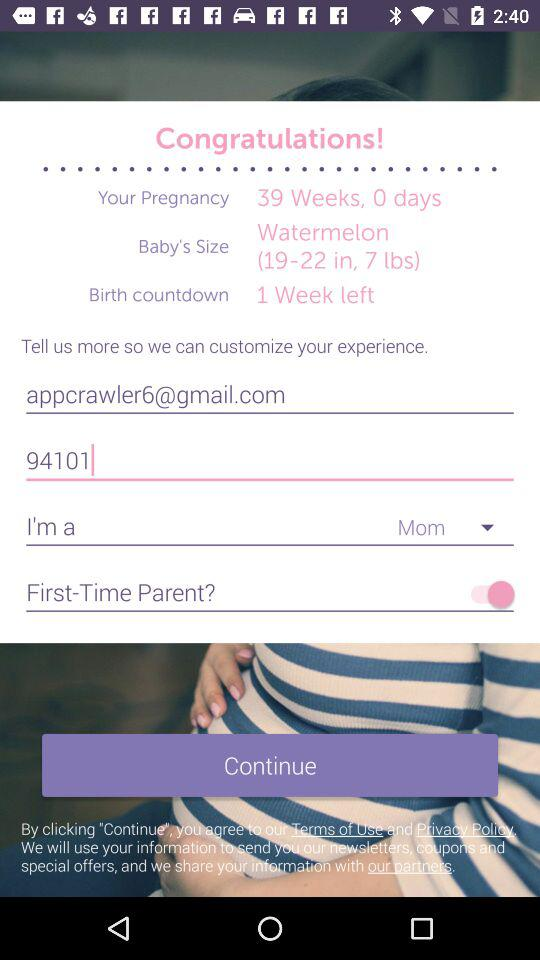What is the email address? The email address is appcrawler6@gmail.com. 